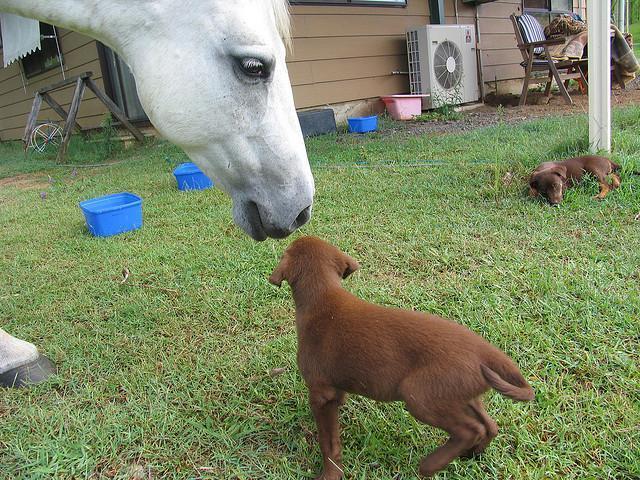How many dogs are in the photo?
Give a very brief answer. 2. How many people are on horseback?
Give a very brief answer. 0. 